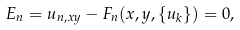<formula> <loc_0><loc_0><loc_500><loc_500>E _ { n } = u _ { n , x y } - F _ { n } ( x , y , \{ u _ { k } \} ) = 0 ,</formula> 